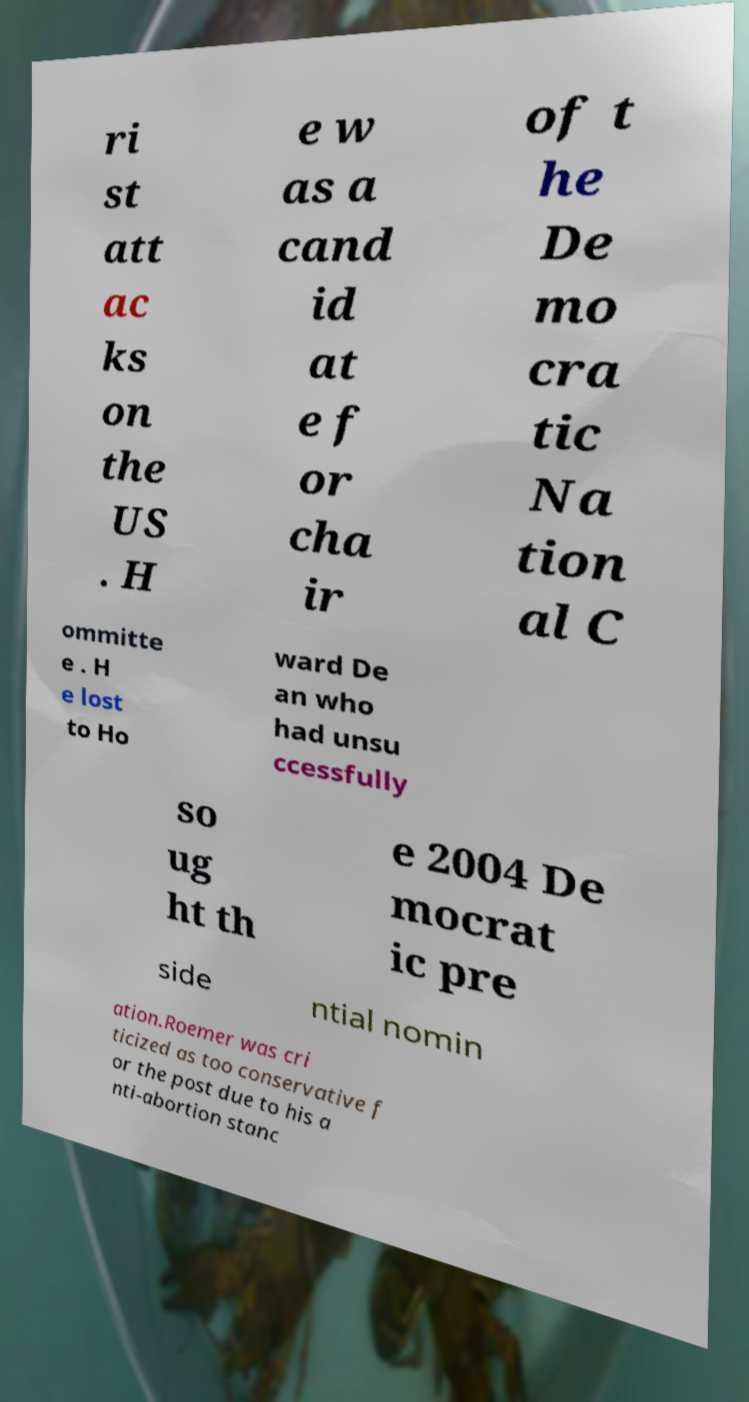What messages or text are displayed in this image? I need them in a readable, typed format. ri st att ac ks on the US . H e w as a cand id at e f or cha ir of t he De mo cra tic Na tion al C ommitte e . H e lost to Ho ward De an who had unsu ccessfully so ug ht th e 2004 De mocrat ic pre side ntial nomin ation.Roemer was cri ticized as too conservative f or the post due to his a nti-abortion stanc 